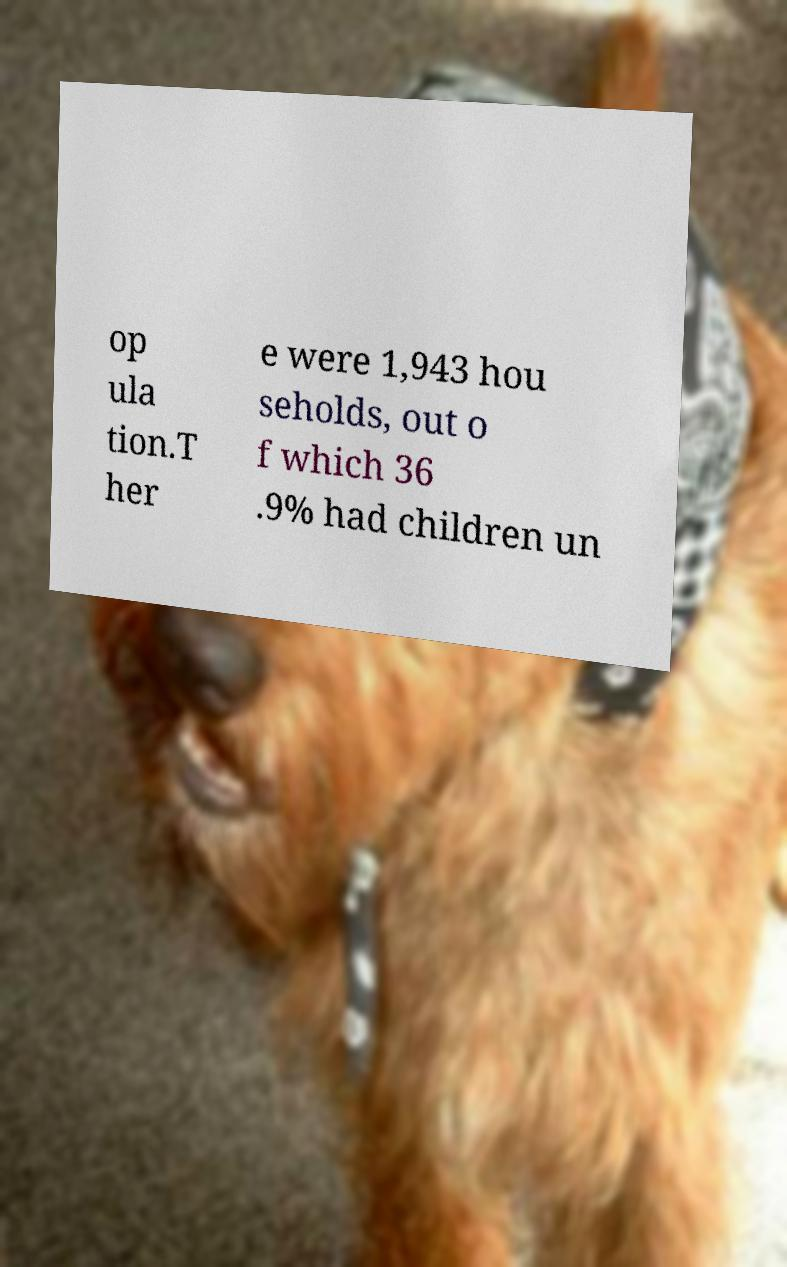Could you extract and type out the text from this image? op ula tion.T her e were 1,943 hou seholds, out o f which 36 .9% had children un 